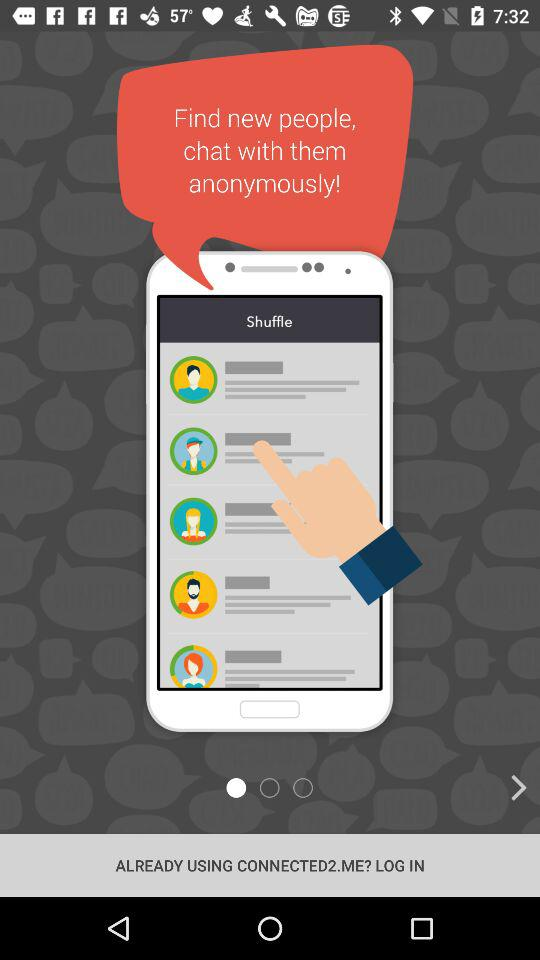What is the application name? The application name is "CONNECTED2.ME". 